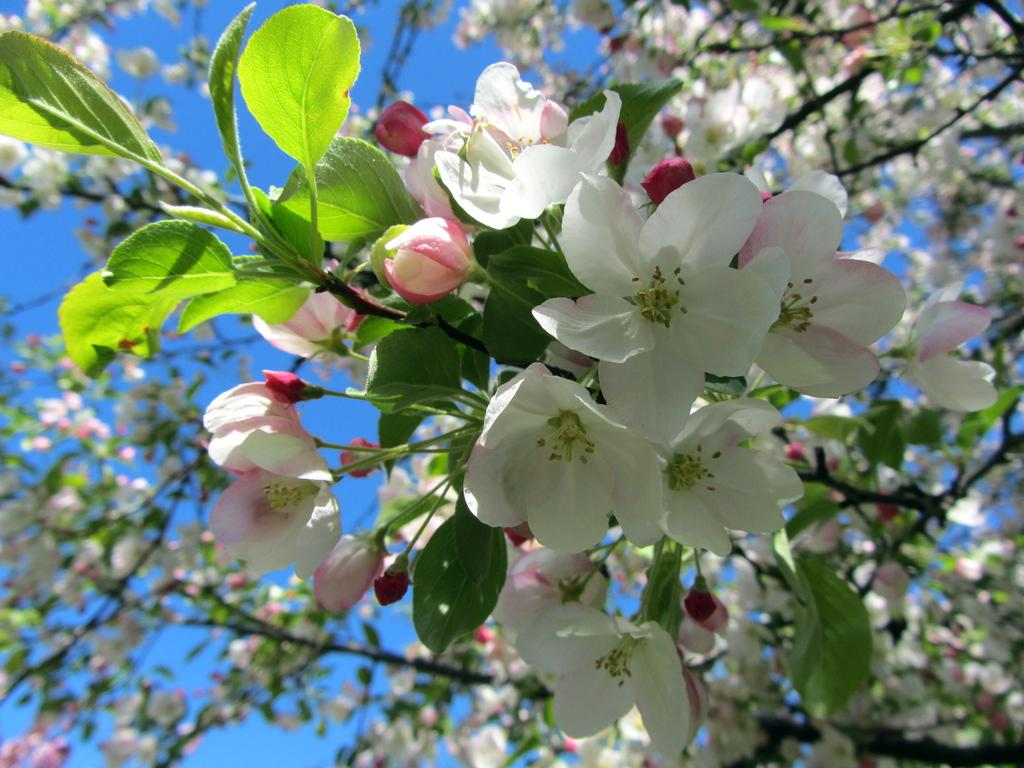What type of vegetation can be seen in the image? There are trees in the image. What additional feature can be observed on the trees? The trees have flowers. Where is the curtain located in the image? There is no curtain present in the image; it only features trees with flowers. 